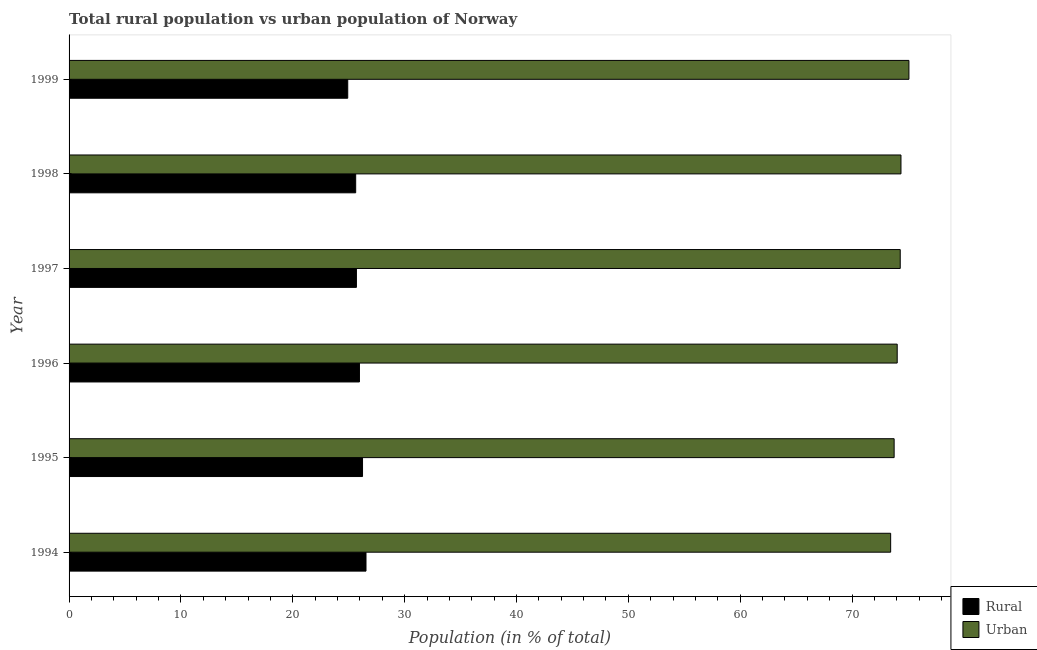Are the number of bars per tick equal to the number of legend labels?
Offer a very short reply. Yes. Are the number of bars on each tick of the Y-axis equal?
Keep it short and to the point. Yes. How many bars are there on the 6th tick from the bottom?
Offer a terse response. 2. What is the urban population in 1995?
Offer a very short reply. 73.76. Across all years, what is the maximum urban population?
Make the answer very short. 75.09. Across all years, what is the minimum rural population?
Your answer should be very brief. 24.91. In which year was the urban population maximum?
Provide a succinct answer. 1999. In which year was the urban population minimum?
Ensure brevity in your answer.  1994. What is the total rural population in the graph?
Ensure brevity in your answer.  154.97. What is the difference between the urban population in 1995 and that in 1999?
Provide a succinct answer. -1.32. What is the difference between the urban population in 1999 and the rural population in 1998?
Ensure brevity in your answer.  49.46. What is the average urban population per year?
Provide a short and direct response. 74.17. In the year 1995, what is the difference between the rural population and urban population?
Offer a very short reply. -47.53. Is the urban population in 1994 less than that in 1996?
Offer a terse response. Yes. Is the difference between the rural population in 1996 and 1999 greater than the difference between the urban population in 1996 and 1999?
Make the answer very short. Yes. What is the difference between the highest and the second highest urban population?
Keep it short and to the point. 0.71. What is the difference between the highest and the lowest rural population?
Make the answer very short. 1.63. What does the 1st bar from the top in 1994 represents?
Your answer should be very brief. Urban. What does the 1st bar from the bottom in 1998 represents?
Your answer should be very brief. Rural. How many bars are there?
Your answer should be very brief. 12. Are all the bars in the graph horizontal?
Offer a terse response. Yes. What is the difference between two consecutive major ticks on the X-axis?
Give a very brief answer. 10. Are the values on the major ticks of X-axis written in scientific E-notation?
Provide a short and direct response. No. Does the graph contain any zero values?
Provide a short and direct response. No. Where does the legend appear in the graph?
Provide a succinct answer. Bottom right. How are the legend labels stacked?
Offer a very short reply. Vertical. What is the title of the graph?
Offer a terse response. Total rural population vs urban population of Norway. Does "Girls" appear as one of the legend labels in the graph?
Make the answer very short. No. What is the label or title of the X-axis?
Make the answer very short. Population (in % of total). What is the Population (in % of total) of Rural in 1994?
Your answer should be very brief. 26.55. What is the Population (in % of total) of Urban in 1994?
Your response must be concise. 73.45. What is the Population (in % of total) in Rural in 1995?
Offer a terse response. 26.24. What is the Population (in % of total) of Urban in 1995?
Give a very brief answer. 73.76. What is the Population (in % of total) in Rural in 1996?
Ensure brevity in your answer.  25.96. What is the Population (in % of total) in Urban in 1996?
Provide a short and direct response. 74.04. What is the Population (in % of total) of Rural in 1997?
Provide a short and direct response. 25.69. What is the Population (in % of total) of Urban in 1997?
Your response must be concise. 74.31. What is the Population (in % of total) in Rural in 1998?
Your response must be concise. 25.62. What is the Population (in % of total) in Urban in 1998?
Keep it short and to the point. 74.38. What is the Population (in % of total) in Rural in 1999?
Offer a terse response. 24.91. What is the Population (in % of total) of Urban in 1999?
Keep it short and to the point. 75.09. Across all years, what is the maximum Population (in % of total) in Rural?
Your answer should be very brief. 26.55. Across all years, what is the maximum Population (in % of total) in Urban?
Your answer should be very brief. 75.09. Across all years, what is the minimum Population (in % of total) of Rural?
Ensure brevity in your answer.  24.91. Across all years, what is the minimum Population (in % of total) of Urban?
Keep it short and to the point. 73.45. What is the total Population (in % of total) of Rural in the graph?
Offer a very short reply. 154.97. What is the total Population (in % of total) in Urban in the graph?
Make the answer very short. 445.03. What is the difference between the Population (in % of total) of Rural in 1994 and that in 1995?
Ensure brevity in your answer.  0.31. What is the difference between the Population (in % of total) in Urban in 1994 and that in 1995?
Give a very brief answer. -0.31. What is the difference between the Population (in % of total) in Rural in 1994 and that in 1996?
Provide a short and direct response. 0.59. What is the difference between the Population (in % of total) of Urban in 1994 and that in 1996?
Your answer should be very brief. -0.59. What is the difference between the Population (in % of total) in Rural in 1994 and that in 1997?
Your response must be concise. 0.86. What is the difference between the Population (in % of total) in Urban in 1994 and that in 1997?
Offer a very short reply. -0.86. What is the difference between the Population (in % of total) in Rural in 1994 and that in 1998?
Your answer should be compact. 0.92. What is the difference between the Population (in % of total) of Urban in 1994 and that in 1998?
Make the answer very short. -0.92. What is the difference between the Population (in % of total) of Rural in 1994 and that in 1999?
Give a very brief answer. 1.63. What is the difference between the Population (in % of total) in Urban in 1994 and that in 1999?
Give a very brief answer. -1.63. What is the difference between the Population (in % of total) of Rural in 1995 and that in 1996?
Your answer should be very brief. 0.28. What is the difference between the Population (in % of total) in Urban in 1995 and that in 1996?
Provide a succinct answer. -0.28. What is the difference between the Population (in % of total) of Rural in 1995 and that in 1997?
Your response must be concise. 0.55. What is the difference between the Population (in % of total) in Urban in 1995 and that in 1997?
Make the answer very short. -0.55. What is the difference between the Population (in % of total) of Rural in 1995 and that in 1998?
Ensure brevity in your answer.  0.61. What is the difference between the Population (in % of total) of Urban in 1995 and that in 1998?
Make the answer very short. -0.61. What is the difference between the Population (in % of total) of Rural in 1995 and that in 1999?
Provide a short and direct response. 1.32. What is the difference between the Population (in % of total) of Urban in 1995 and that in 1999?
Your answer should be compact. -1.32. What is the difference between the Population (in % of total) of Rural in 1996 and that in 1997?
Keep it short and to the point. 0.27. What is the difference between the Population (in % of total) in Urban in 1996 and that in 1997?
Make the answer very short. -0.27. What is the difference between the Population (in % of total) in Rural in 1996 and that in 1998?
Provide a succinct answer. 0.34. What is the difference between the Population (in % of total) of Urban in 1996 and that in 1998?
Offer a terse response. -0.34. What is the difference between the Population (in % of total) in Rural in 1996 and that in 1999?
Provide a short and direct response. 1.05. What is the difference between the Population (in % of total) in Urban in 1996 and that in 1999?
Offer a terse response. -1.05. What is the difference between the Population (in % of total) in Rural in 1997 and that in 1998?
Offer a very short reply. 0.07. What is the difference between the Population (in % of total) in Urban in 1997 and that in 1998?
Provide a short and direct response. -0.07. What is the difference between the Population (in % of total) of Rural in 1997 and that in 1999?
Your answer should be compact. 0.78. What is the difference between the Population (in % of total) of Urban in 1997 and that in 1999?
Provide a succinct answer. -0.78. What is the difference between the Population (in % of total) in Rural in 1998 and that in 1999?
Provide a succinct answer. 0.71. What is the difference between the Population (in % of total) in Urban in 1998 and that in 1999?
Give a very brief answer. -0.71. What is the difference between the Population (in % of total) in Rural in 1994 and the Population (in % of total) in Urban in 1995?
Your answer should be very brief. -47.22. What is the difference between the Population (in % of total) of Rural in 1994 and the Population (in % of total) of Urban in 1996?
Your answer should be very brief. -47.49. What is the difference between the Population (in % of total) in Rural in 1994 and the Population (in % of total) in Urban in 1997?
Make the answer very short. -47.76. What is the difference between the Population (in % of total) in Rural in 1994 and the Population (in % of total) in Urban in 1998?
Your answer should be very brief. -47.83. What is the difference between the Population (in % of total) in Rural in 1994 and the Population (in % of total) in Urban in 1999?
Your response must be concise. -48.54. What is the difference between the Population (in % of total) in Rural in 1995 and the Population (in % of total) in Urban in 1996?
Offer a terse response. -47.8. What is the difference between the Population (in % of total) of Rural in 1995 and the Population (in % of total) of Urban in 1997?
Offer a terse response. -48.07. What is the difference between the Population (in % of total) in Rural in 1995 and the Population (in % of total) in Urban in 1998?
Your answer should be very brief. -48.14. What is the difference between the Population (in % of total) of Rural in 1995 and the Population (in % of total) of Urban in 1999?
Your answer should be very brief. -48.85. What is the difference between the Population (in % of total) in Rural in 1996 and the Population (in % of total) in Urban in 1997?
Offer a terse response. -48.35. What is the difference between the Population (in % of total) of Rural in 1996 and the Population (in % of total) of Urban in 1998?
Offer a very short reply. -48.41. What is the difference between the Population (in % of total) in Rural in 1996 and the Population (in % of total) in Urban in 1999?
Keep it short and to the point. -49.12. What is the difference between the Population (in % of total) of Rural in 1997 and the Population (in % of total) of Urban in 1998?
Provide a succinct answer. -48.68. What is the difference between the Population (in % of total) in Rural in 1997 and the Population (in % of total) in Urban in 1999?
Ensure brevity in your answer.  -49.4. What is the difference between the Population (in % of total) in Rural in 1998 and the Population (in % of total) in Urban in 1999?
Make the answer very short. -49.46. What is the average Population (in % of total) in Rural per year?
Your answer should be very brief. 25.83. What is the average Population (in % of total) of Urban per year?
Offer a terse response. 74.17. In the year 1994, what is the difference between the Population (in % of total) of Rural and Population (in % of total) of Urban?
Your response must be concise. -46.91. In the year 1995, what is the difference between the Population (in % of total) of Rural and Population (in % of total) of Urban?
Provide a short and direct response. -47.53. In the year 1996, what is the difference between the Population (in % of total) of Rural and Population (in % of total) of Urban?
Give a very brief answer. -48.08. In the year 1997, what is the difference between the Population (in % of total) of Rural and Population (in % of total) of Urban?
Offer a terse response. -48.62. In the year 1998, what is the difference between the Population (in % of total) of Rural and Population (in % of total) of Urban?
Keep it short and to the point. -48.75. In the year 1999, what is the difference between the Population (in % of total) in Rural and Population (in % of total) in Urban?
Offer a very short reply. -50.17. What is the ratio of the Population (in % of total) in Rural in 1994 to that in 1995?
Offer a terse response. 1.01. What is the ratio of the Population (in % of total) in Rural in 1994 to that in 1996?
Provide a short and direct response. 1.02. What is the ratio of the Population (in % of total) of Rural in 1994 to that in 1997?
Provide a succinct answer. 1.03. What is the ratio of the Population (in % of total) in Urban in 1994 to that in 1997?
Your answer should be compact. 0.99. What is the ratio of the Population (in % of total) of Rural in 1994 to that in 1998?
Your answer should be very brief. 1.04. What is the ratio of the Population (in % of total) in Urban in 1994 to that in 1998?
Provide a succinct answer. 0.99. What is the ratio of the Population (in % of total) of Rural in 1994 to that in 1999?
Give a very brief answer. 1.07. What is the ratio of the Population (in % of total) of Urban in 1994 to that in 1999?
Your response must be concise. 0.98. What is the ratio of the Population (in % of total) of Rural in 1995 to that in 1996?
Give a very brief answer. 1.01. What is the ratio of the Population (in % of total) of Rural in 1995 to that in 1997?
Keep it short and to the point. 1.02. What is the ratio of the Population (in % of total) in Urban in 1995 to that in 1997?
Offer a terse response. 0.99. What is the ratio of the Population (in % of total) of Rural in 1995 to that in 1998?
Offer a terse response. 1.02. What is the ratio of the Population (in % of total) of Rural in 1995 to that in 1999?
Your response must be concise. 1.05. What is the ratio of the Population (in % of total) of Urban in 1995 to that in 1999?
Make the answer very short. 0.98. What is the ratio of the Population (in % of total) of Rural in 1996 to that in 1997?
Provide a short and direct response. 1.01. What is the ratio of the Population (in % of total) of Urban in 1996 to that in 1997?
Your answer should be very brief. 1. What is the ratio of the Population (in % of total) in Rural in 1996 to that in 1998?
Your answer should be compact. 1.01. What is the ratio of the Population (in % of total) of Urban in 1996 to that in 1998?
Your response must be concise. 1. What is the ratio of the Population (in % of total) of Rural in 1996 to that in 1999?
Give a very brief answer. 1.04. What is the ratio of the Population (in % of total) in Urban in 1996 to that in 1999?
Your response must be concise. 0.99. What is the ratio of the Population (in % of total) of Urban in 1997 to that in 1998?
Your response must be concise. 1. What is the ratio of the Population (in % of total) of Rural in 1997 to that in 1999?
Make the answer very short. 1.03. What is the ratio of the Population (in % of total) in Urban in 1997 to that in 1999?
Provide a succinct answer. 0.99. What is the ratio of the Population (in % of total) in Rural in 1998 to that in 1999?
Your answer should be compact. 1.03. What is the difference between the highest and the second highest Population (in % of total) of Rural?
Make the answer very short. 0.31. What is the difference between the highest and the second highest Population (in % of total) of Urban?
Ensure brevity in your answer.  0.71. What is the difference between the highest and the lowest Population (in % of total) in Rural?
Provide a short and direct response. 1.63. What is the difference between the highest and the lowest Population (in % of total) in Urban?
Your response must be concise. 1.63. 